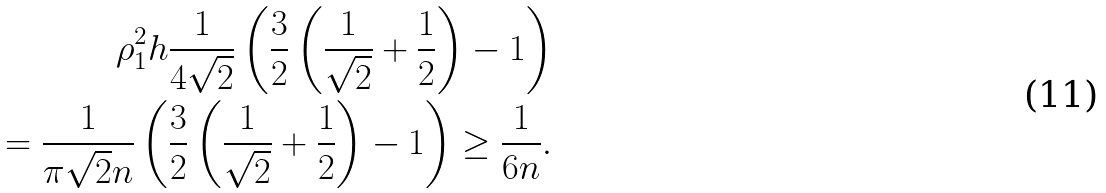Convert formula to latex. <formula><loc_0><loc_0><loc_500><loc_500>\rho _ { 1 } ^ { 2 } h \frac { 1 } { 4 \sqrt { 2 } } \left ( \frac { 3 } { 2 } \left ( \frac { 1 } { \sqrt { 2 } } + \frac { 1 } { 2 } \right ) - 1 \right ) \\ = \frac { 1 } { \pi \sqrt { 2 } n } \left ( \frac { 3 } { 2 } \left ( \frac { 1 } { \sqrt { 2 } } + \frac { 1 } { 2 } \right ) - 1 \right ) \geq \frac { 1 } { 6 n } .</formula> 